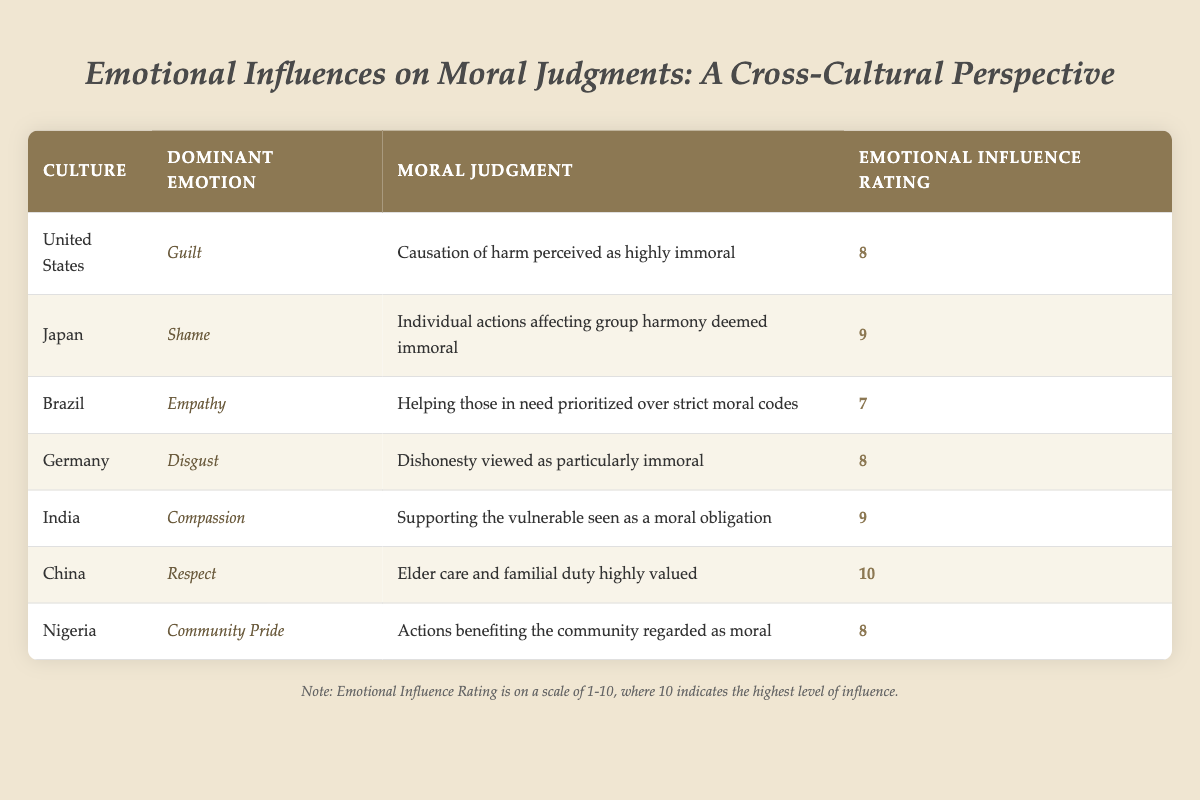What is the dominant emotion related to moral judgments in India? According to the table, India has 'Compassion' as the dominant emotion influencing moral judgments.
Answer: Compassion Which culture has the highest Emotional Influence Rating? Referring to the table, China has the highest Emotional Influence Rating of 10, indicating the strongest emotional influence on moral judgments.
Answer: China What is the average Emotional Influence Rating across all cultures listed? To calculate the average, sum all the Emotional Influence Ratings: (8 + 9 + 7 + 8 + 9 + 10 + 8) = 59. There are 7 cultures in total, so the average is 59 / 7, which equals approximately 8.43.
Answer: 8.43 Does Brazil prioritize helping those in need over strict moral codes as immoral? Based on the table, Brazil's moral judgment reflects that helping those in need is prioritized, indicating these actions are seen as moral rather than immoral.
Answer: No Which cultures view dishonesty as particularly immoral? The table specifies that Germany views dishonesty as particularly immoral based on the corresponding moral judgment.
Answer: Germany 